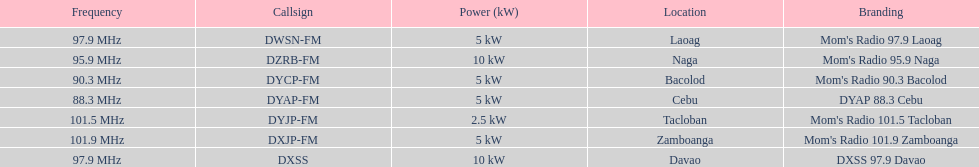What are the total number of radio stations on this list? 7. 